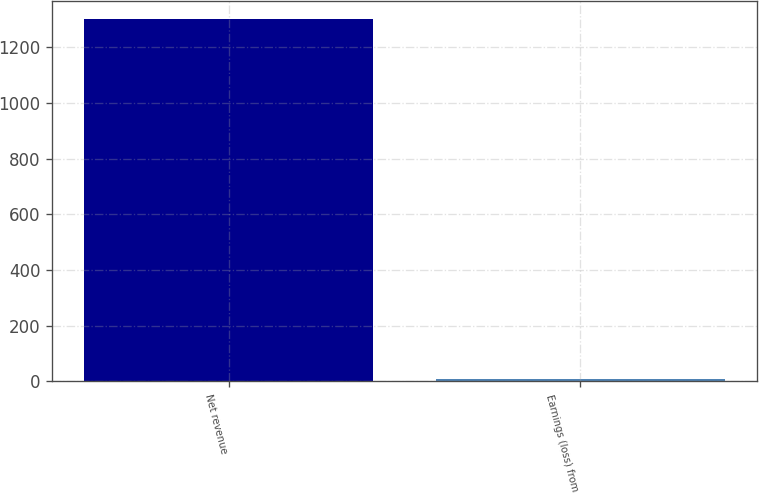Convert chart. <chart><loc_0><loc_0><loc_500><loc_500><bar_chart><fcel>Net revenue<fcel>Earnings (loss) from<nl><fcel>1301<fcel>6.5<nl></chart> 